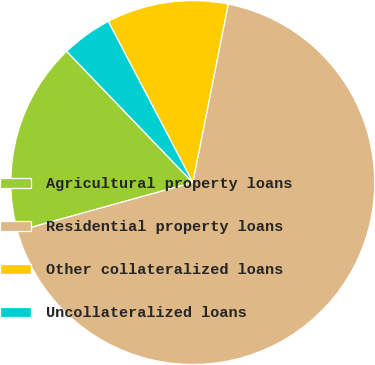Convert chart to OTSL. <chart><loc_0><loc_0><loc_500><loc_500><pie_chart><fcel>Agricultural property loans<fcel>Residential property loans<fcel>Other collateralized loans<fcel>Uncollateralized loans<nl><fcel>17.12%<fcel>67.57%<fcel>10.81%<fcel>4.5%<nl></chart> 